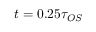<formula> <loc_0><loc_0><loc_500><loc_500>t = 0 . 2 5 \tau _ { O S }</formula> 